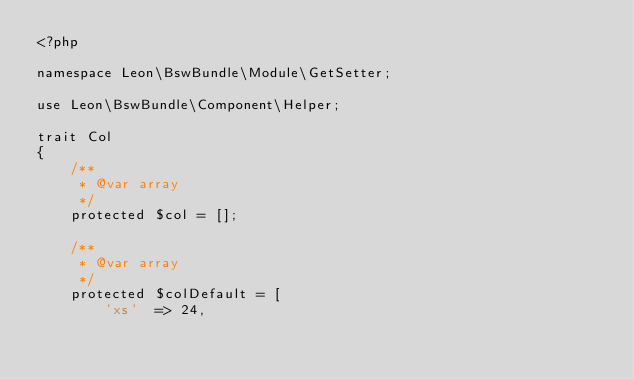Convert code to text. <code><loc_0><loc_0><loc_500><loc_500><_PHP_><?php

namespace Leon\BswBundle\Module\GetSetter;

use Leon\BswBundle\Component\Helper;

trait Col
{
    /**
     * @var array
     */
    protected $col = [];

    /**
     * @var array
     */
    protected $colDefault = [
        'xs'  => 24,</code> 